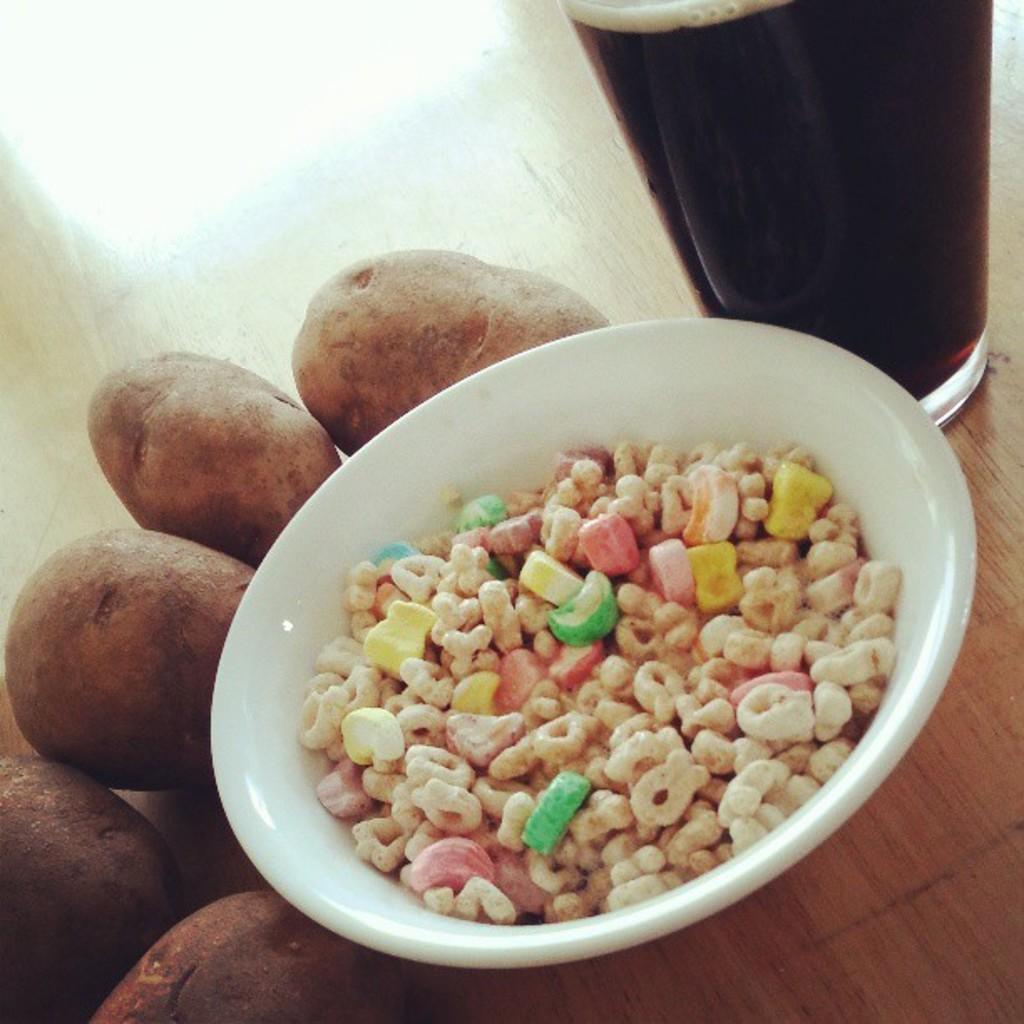What piece of furniture is present in the image? There is a table in the image. What is on the table? There is a glass of juice, potatoes, and a bowl with flakes on the table. What type of sheet is covering the potatoes in the image? There is no sheet covering the potatoes in the image; they are simply placed on the table. 